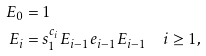<formula> <loc_0><loc_0><loc_500><loc_500>E _ { 0 } & = 1 \\ E _ { i } & = s _ { 1 } ^ { c _ { i } } E _ { i - 1 } e _ { i - 1 } E _ { i - 1 } \quad i \geq 1 ,</formula> 